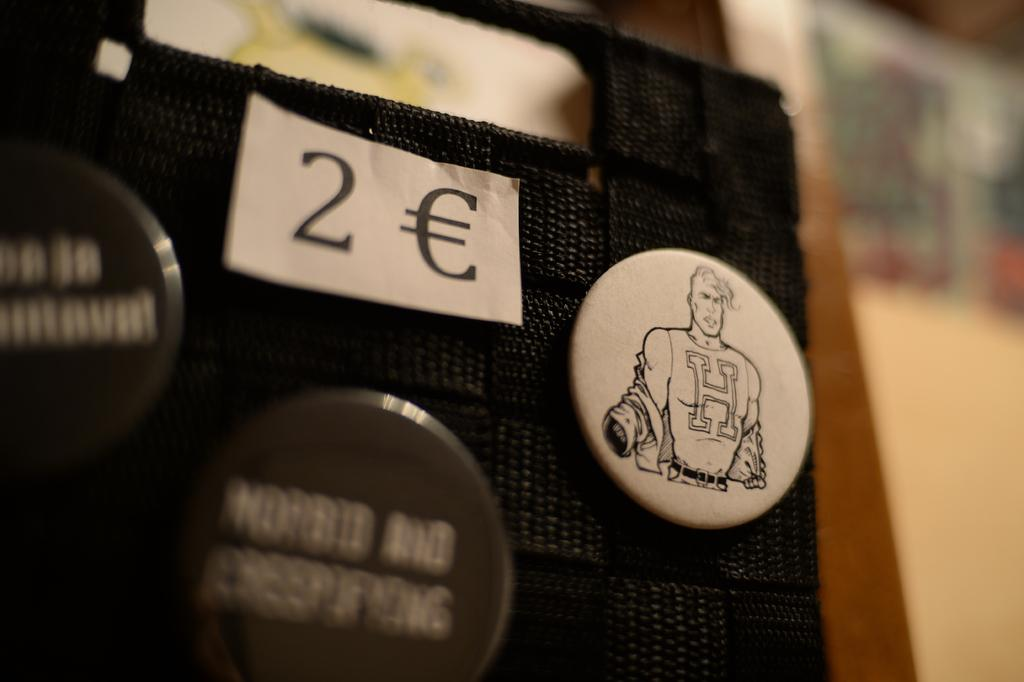How many badges can be seen in the image? There are three badges in the image. What is the color scheme of the badges? The badges are in black and white color. What is the surface to which the badges are attached? The badges are attached to a black color surface. Can you describe the background of the image? The background of the image is blurred. Can you tell me how many strangers are visible in the image? There are no strangers visible in the image; it only features three badges attached to a black surface. What type of nest can be seen in the image? There is no nest present in the image. 